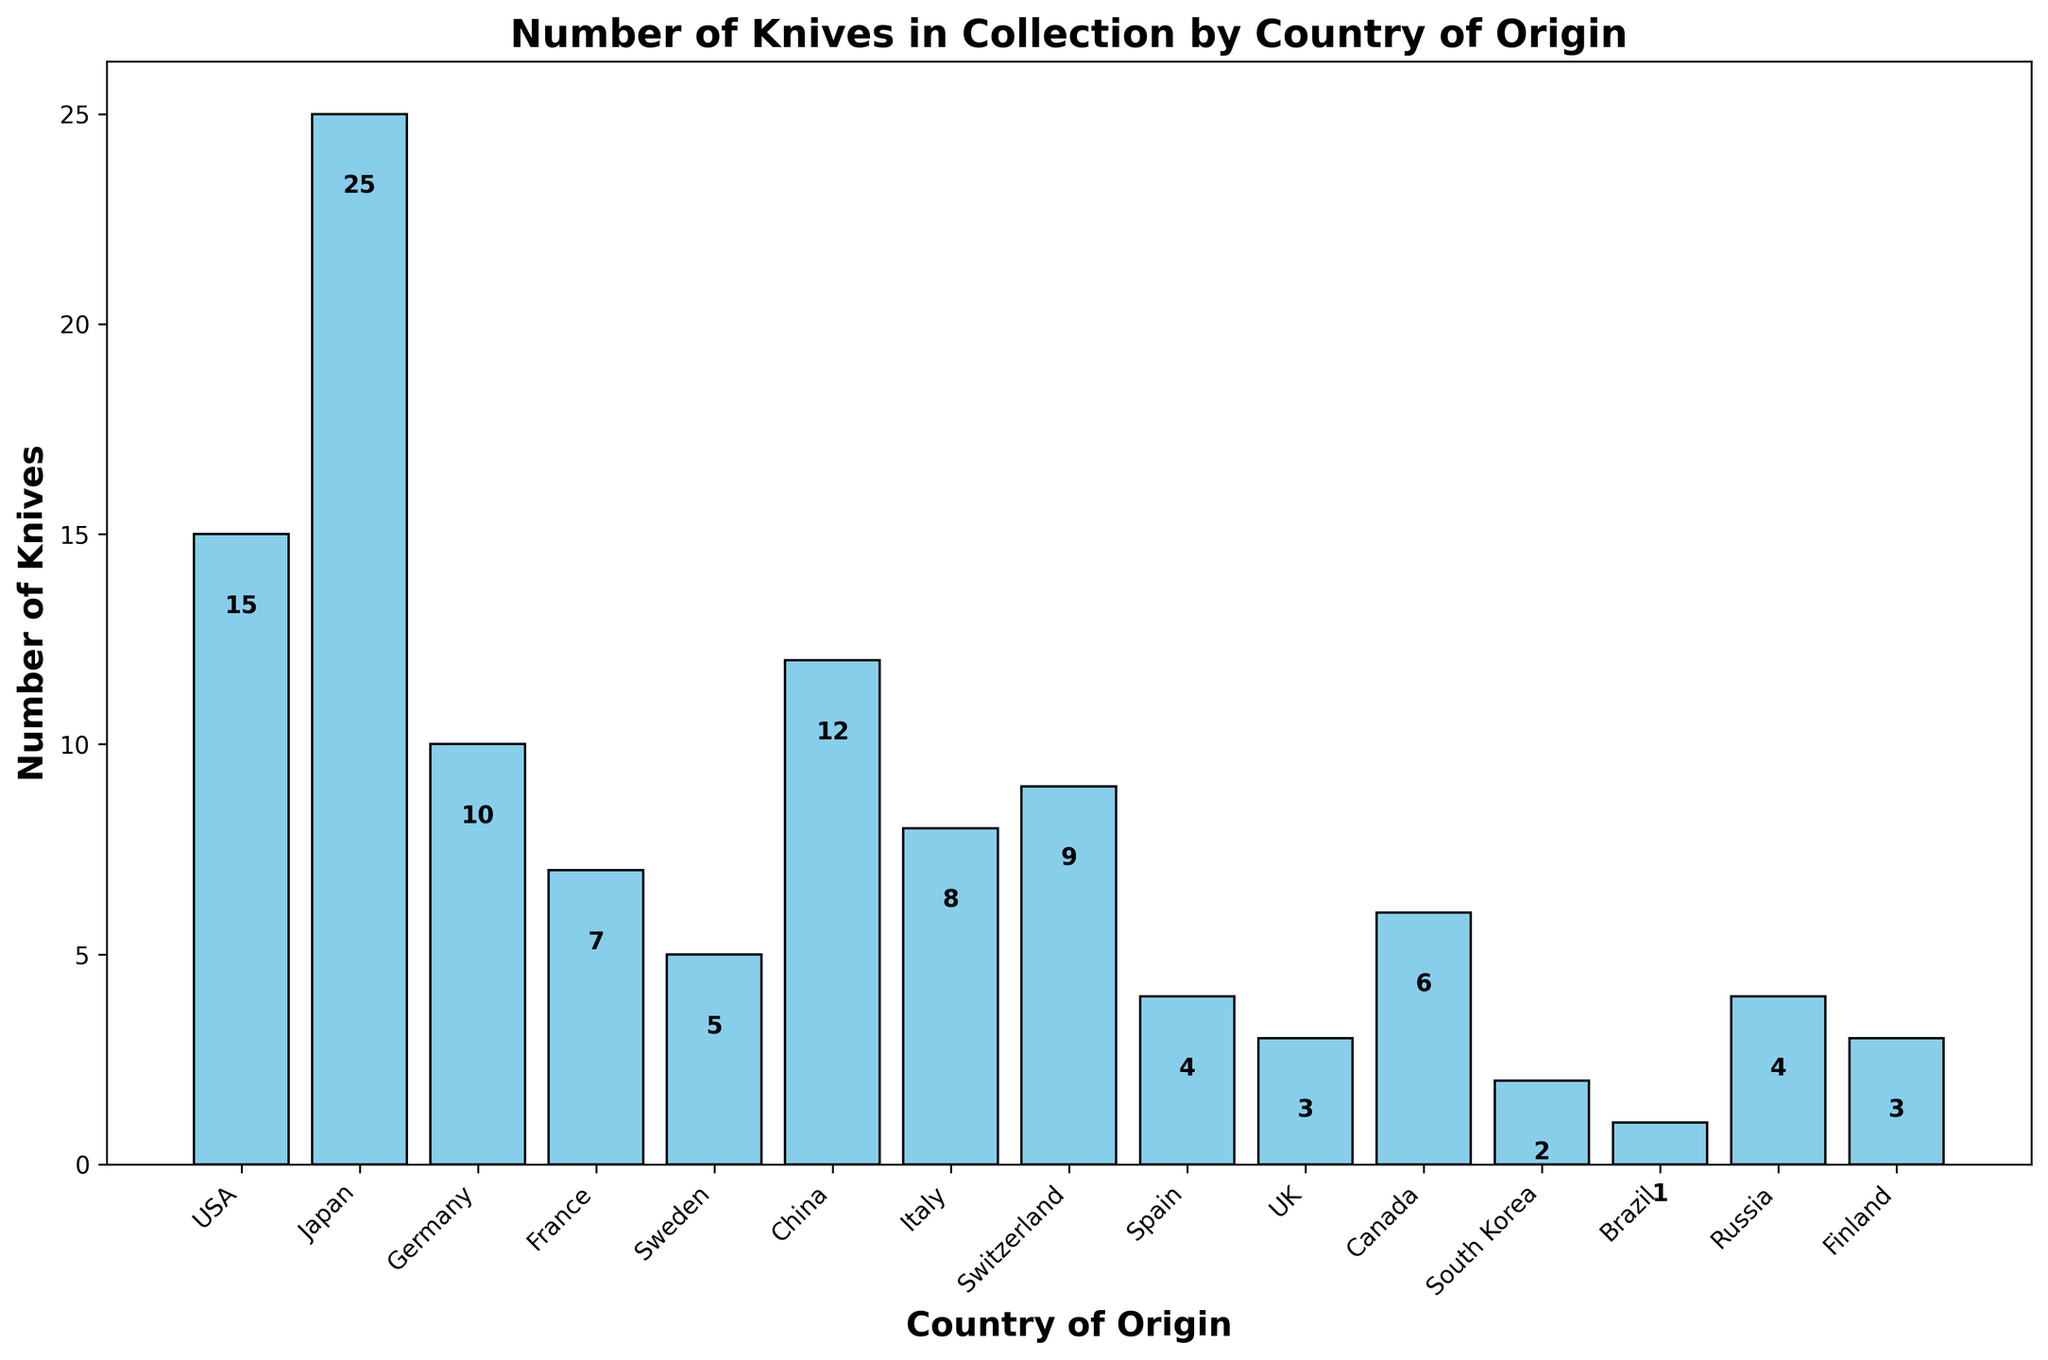How many knives are from Japan and the USA combined? To find the total number of knives from Japan and the USA, add the knives from each country: Japan (25) + USA (15) = 40.
Answer: 40 Which country has the least number of knives in the collection? By examining the heights of the bars, we can see that Brazil has the shortest bar, indicating it has the least number of knives.
Answer: Brazil How many more knives are there from Japan than from France? Subtract the number of knives from France (7) from the number of knives from Japan (25): 25 - 7 = 18.
Answer: 18 Which countries have fewer than 5 knives in the collection? By looking at the bar heights, we see that South Korea (2), Brazil (1), Finland (3), and the UK (3) have bar heights below 5.
Answer: South Korea, Brazil, Finland, UK What is the total number of knives from all countries with less than 10 knives each? Add the knives from Germany (10), France (7), Sweden (5), Italy (8), Switzerland (9), Spain (4), UK (3), Canada (6), South Korea (2), Brazil (1), Russia (4), and Finland (3). Sum = 10 + 7 + 5 + 8 + 9 + 4 + 3 + 6 + 2 + 1 + 4 + 3 = 52.
Answer: 52 How many countries have a higher number of knives than Germany? Count the number of bars taller than Germany's (10): Japan (25), USA (15), and China (12).
Answer: 3 What is the average number of knives per country in the collection? The total number of knives summed across all countries is 114. There are 15 countries. The average number of knives per country is 114 / 15 = 7.6.
Answer: 7.6 Which country has the second-highest number of knives in the collection? By comparing the heights of the bars, we see that Japan has the highest. Next, the USA with 15 knives has the second-highest number.
Answer: USA 